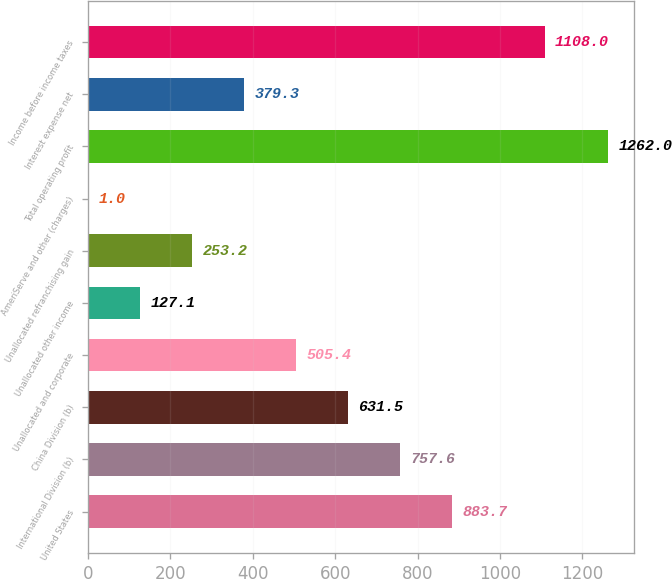Convert chart. <chart><loc_0><loc_0><loc_500><loc_500><bar_chart><fcel>United States<fcel>International Division (b)<fcel>China Division (b)<fcel>Unallocated and corporate<fcel>Unallocated other income<fcel>Unallocated refranchising gain<fcel>AmeriServe and other (charges)<fcel>Total operating profit<fcel>Interest expense net<fcel>Income before income taxes<nl><fcel>883.7<fcel>757.6<fcel>631.5<fcel>505.4<fcel>127.1<fcel>253.2<fcel>1<fcel>1262<fcel>379.3<fcel>1108<nl></chart> 